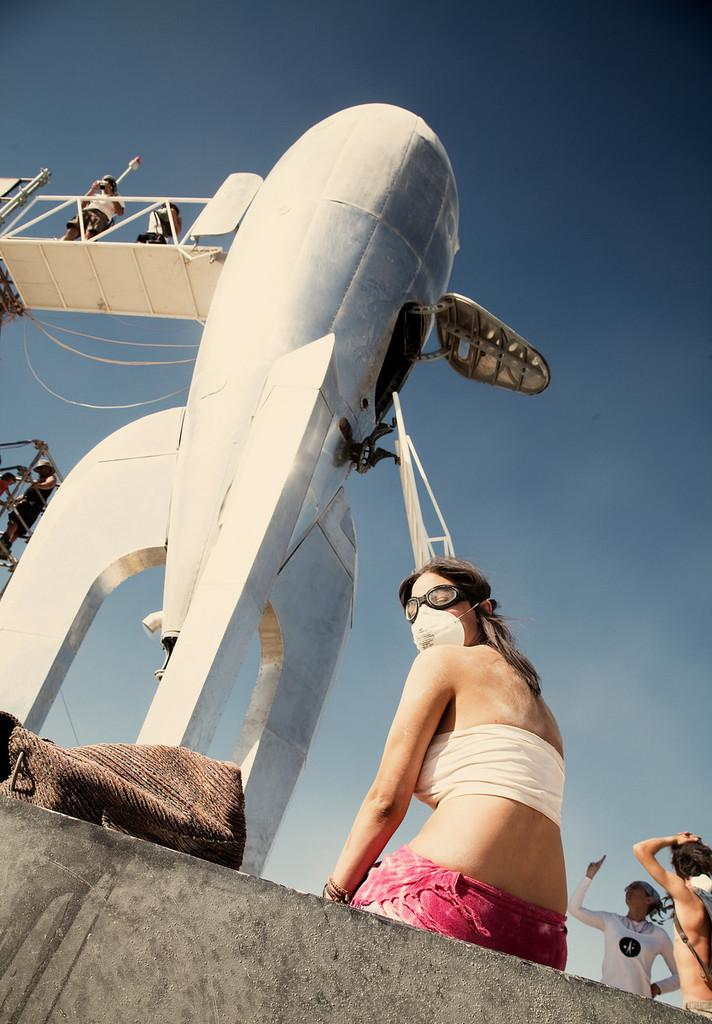How many people are in the image? There are people in the image, but the exact number is not specified. What is the background of the image? There is a wall in the image, and the sky is visible. What objects can be seen in the image? There is a bag, a rocket, railing, and a ladder in the image. What is the overall setting of the image? The image features people, a wall, the sky, and various objects, including a rocket and a ladder. What type of beef is being cooked on the rocket in the image? There is no beef or cooking activity present in the image; the rocket is a separate object in the scene. 